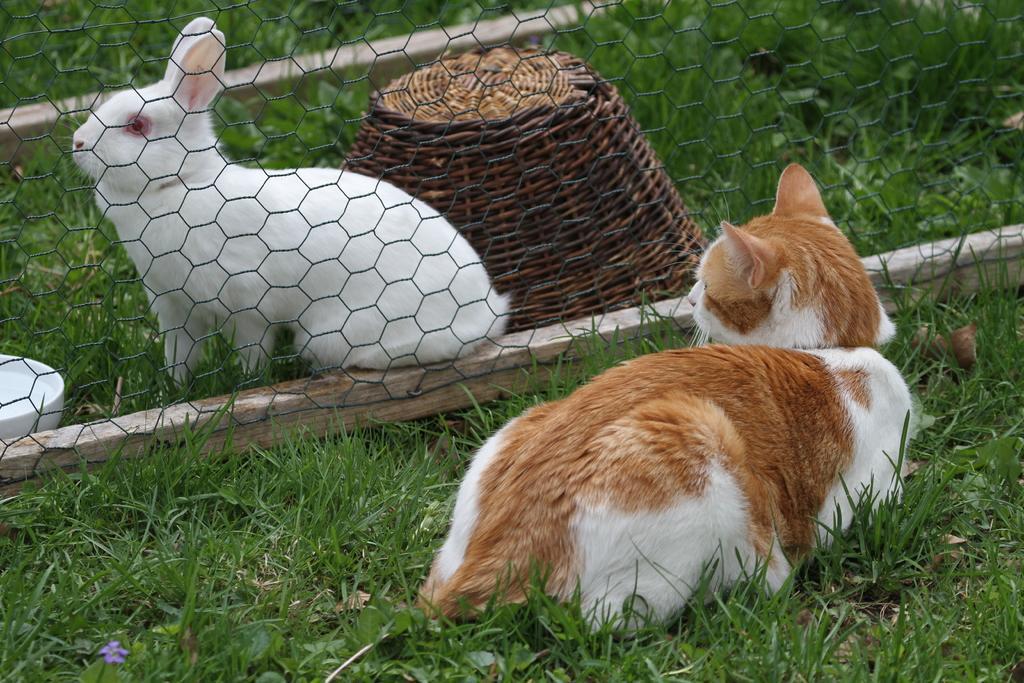Describe this image in one or two sentences. In this image I can see there is a rabbit behind the fence and a cat sitting at the right side, there is some grass on the floor. 